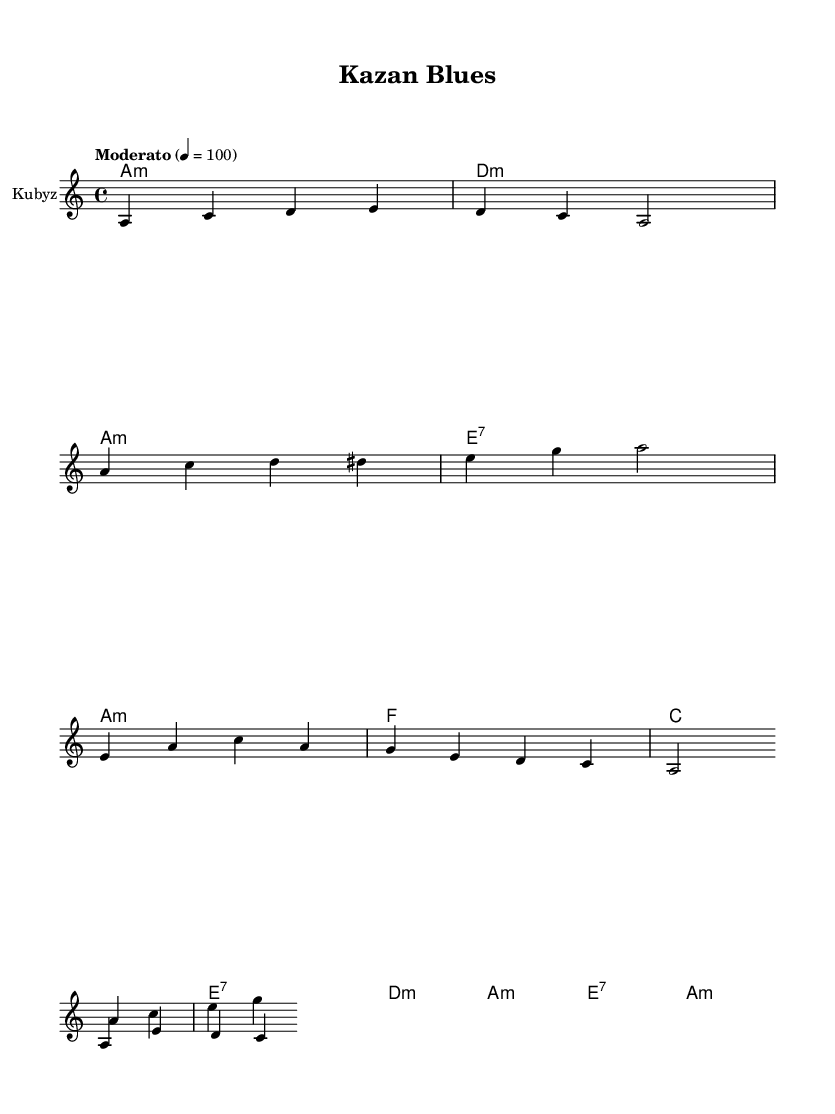What is the key signature of this music? The key signature is A minor, which has no sharps or flats.
Answer: A minor What is the time signature of this music? The time signature is indicated as 4/4, which means there are four beats in a measure.
Answer: 4/4 What tempo marking is used in this piece? The tempo marking is "Moderato," indicating a moderate speed, and the metronome marking is 4 = 100, which refers to 100 beats per minute.
Answer: Moderato Which instruments are featured in this piece? The instruments listed are the Kubyz, Harmonica, and Guitar, as identified in the instrument names set in the score.
Answer: Kubyz, Harmonica, Guitar What is the chord progression for the verse? The chord progression for the verse is A minor, D minor, A minor, and E7, as shown in the chord names section of the score.
Answer: A minor, D minor, A minor, E7 How many measures are in the chorus section? The chorus consists of four measures, each with specific chords listed in the score.
Answer: 4 What is the relationship between the Kubyz and Harmonicas in the bridge section? In the bridge, the melodies for both the Kubyz and Harmonica are played simultaneously, creating a fusion of sounds typical in blues music.
Answer: Simultaneous melodies 